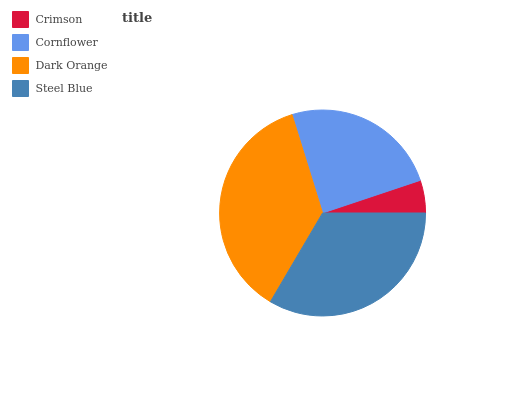Is Crimson the minimum?
Answer yes or no. Yes. Is Dark Orange the maximum?
Answer yes or no. Yes. Is Cornflower the minimum?
Answer yes or no. No. Is Cornflower the maximum?
Answer yes or no. No. Is Cornflower greater than Crimson?
Answer yes or no. Yes. Is Crimson less than Cornflower?
Answer yes or no. Yes. Is Crimson greater than Cornflower?
Answer yes or no. No. Is Cornflower less than Crimson?
Answer yes or no. No. Is Steel Blue the high median?
Answer yes or no. Yes. Is Cornflower the low median?
Answer yes or no. Yes. Is Dark Orange the high median?
Answer yes or no. No. Is Steel Blue the low median?
Answer yes or no. No. 